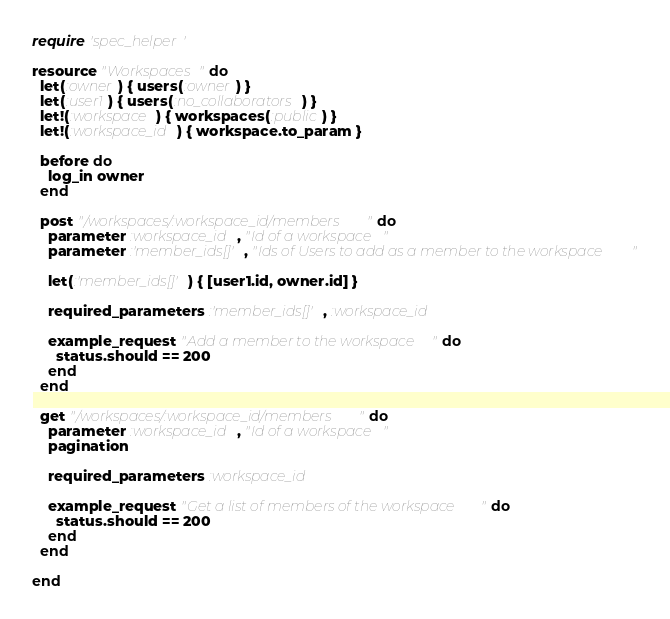Convert code to text. <code><loc_0><loc_0><loc_500><loc_500><_Ruby_>require 'spec_helper'

resource "Workspaces" do
  let(:owner) { users(:owner) }
  let(:user1) { users(:no_collaborators) }
  let!(:workspace) { workspaces(:public) }
  let!(:workspace_id) { workspace.to_param }

  before do
    log_in owner
  end

  post "/workspaces/:workspace_id/members" do
    parameter :workspace_id, "Id of a workspace"
    parameter :'member_ids[]', "Ids of Users to add as a member to the workspace"

    let(:'member_ids[]') { [user1.id, owner.id] }

    required_parameters :'member_ids[]', :workspace_id

    example_request "Add a member to the workspace" do
      status.should == 200
    end
  end

  get "/workspaces/:workspace_id/members" do
    parameter :workspace_id, "Id of a workspace"
    pagination

    required_parameters :workspace_id

    example_request "Get a list of members of the workspace" do
      status.should == 200
    end
  end

end


</code> 